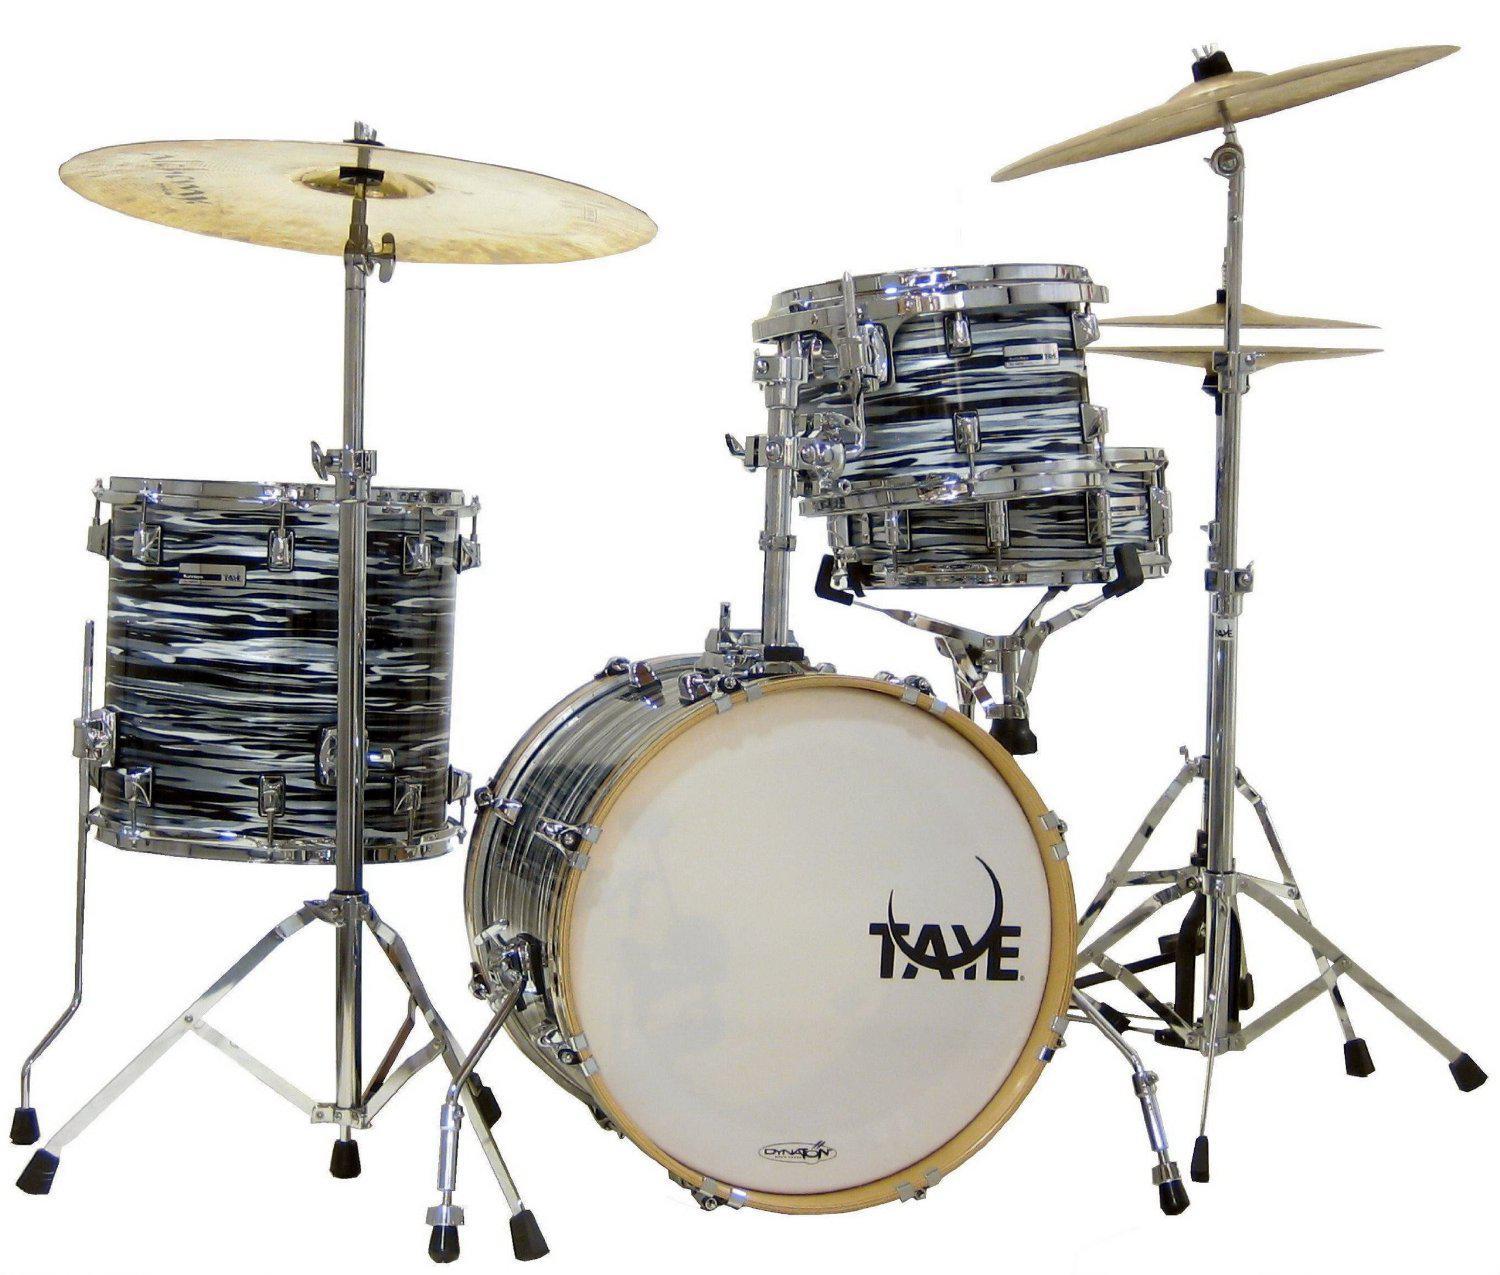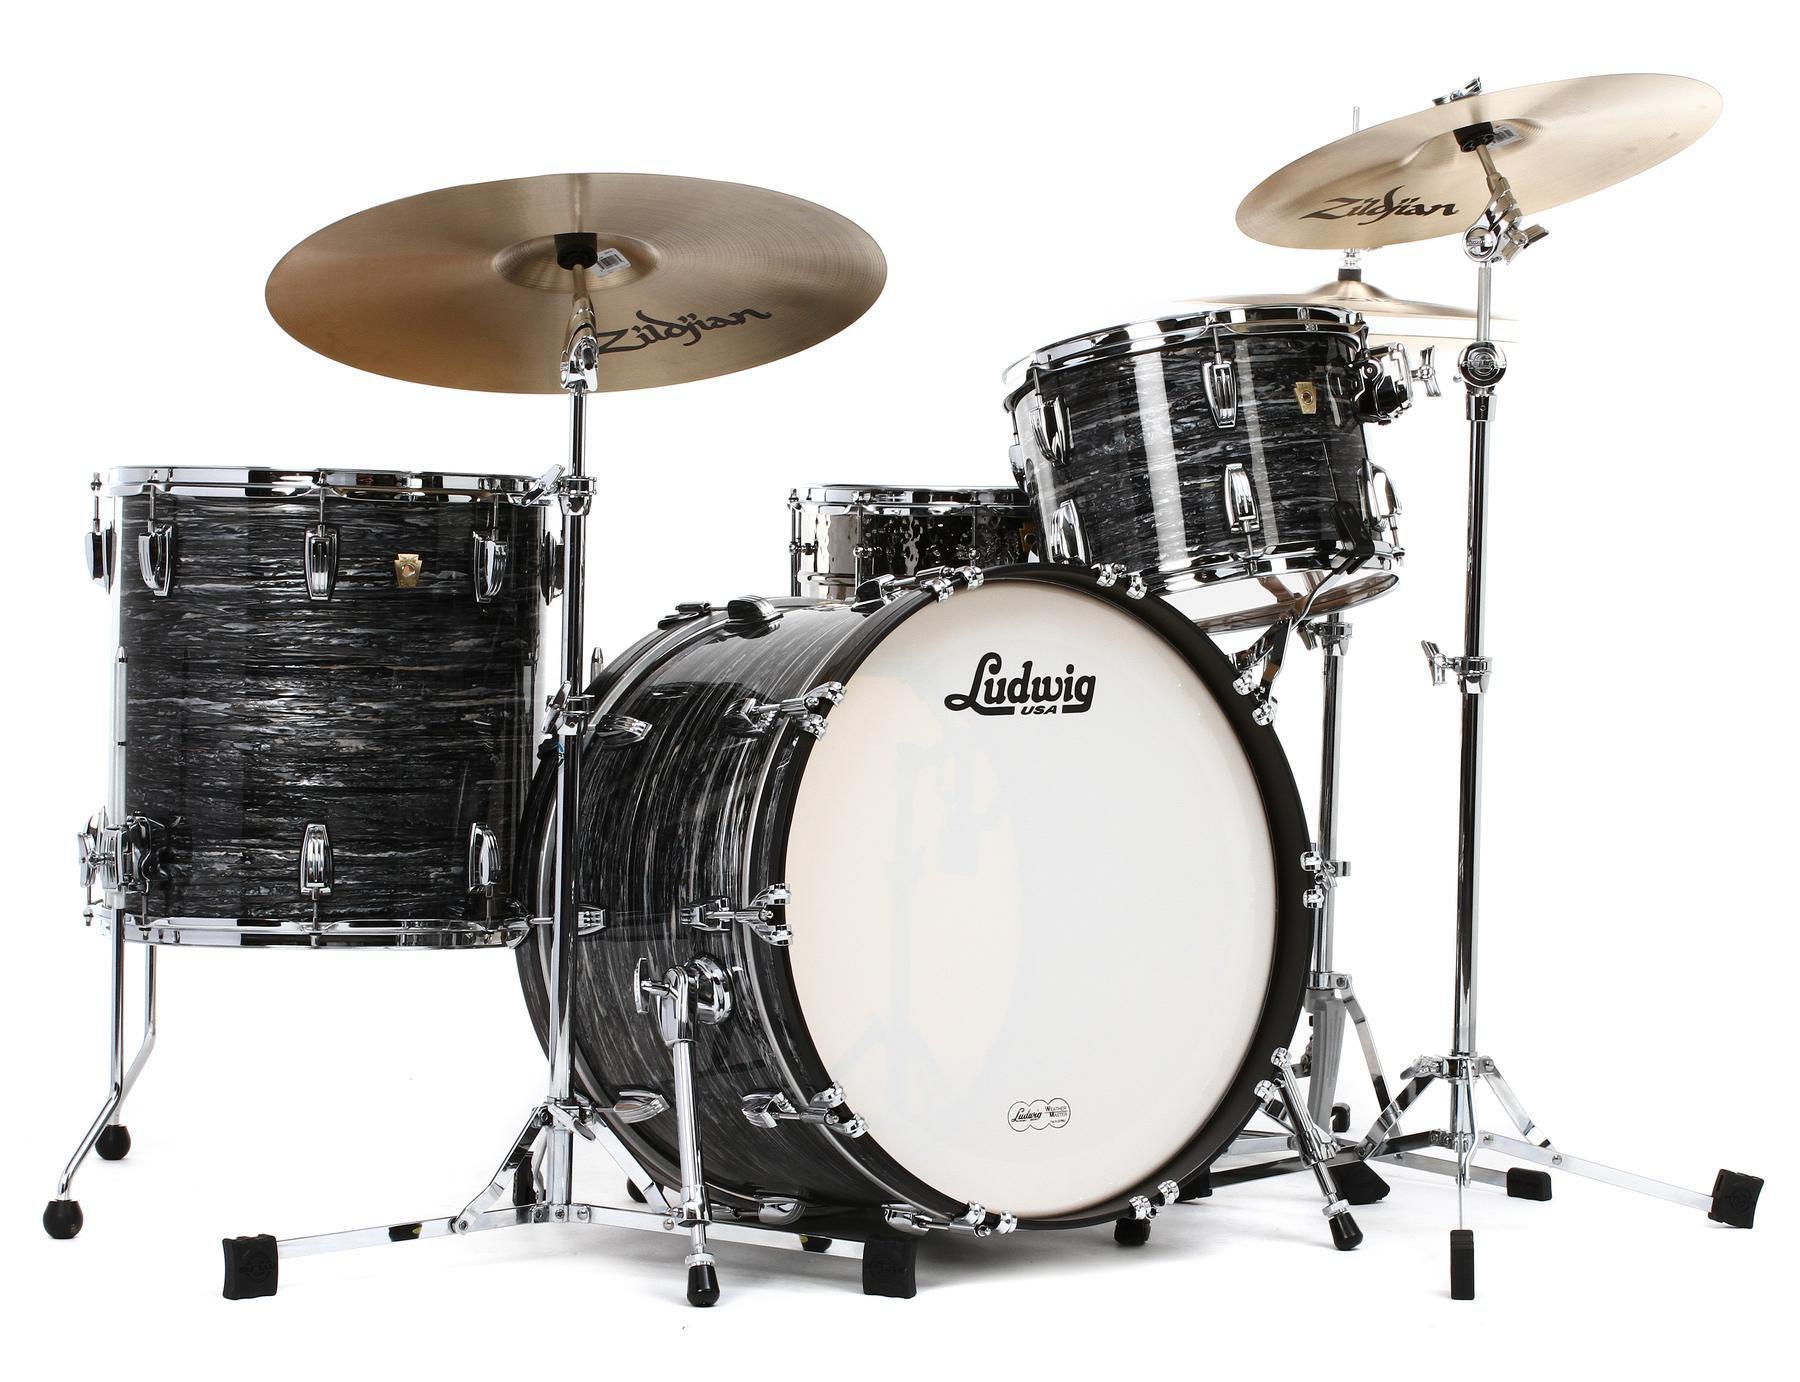The first image is the image on the left, the second image is the image on the right. Analyze the images presented: Is the assertion "Each image features a drum kit with exactly one large drum that has a white side facing outwards and is positioned between cymbals on stands." valid? Answer yes or no. Yes. The first image is the image on the left, the second image is the image on the right. For the images displayed, is the sentence "A single drum set with a white drumskin appears in each of the images." factually correct? Answer yes or no. Yes. 